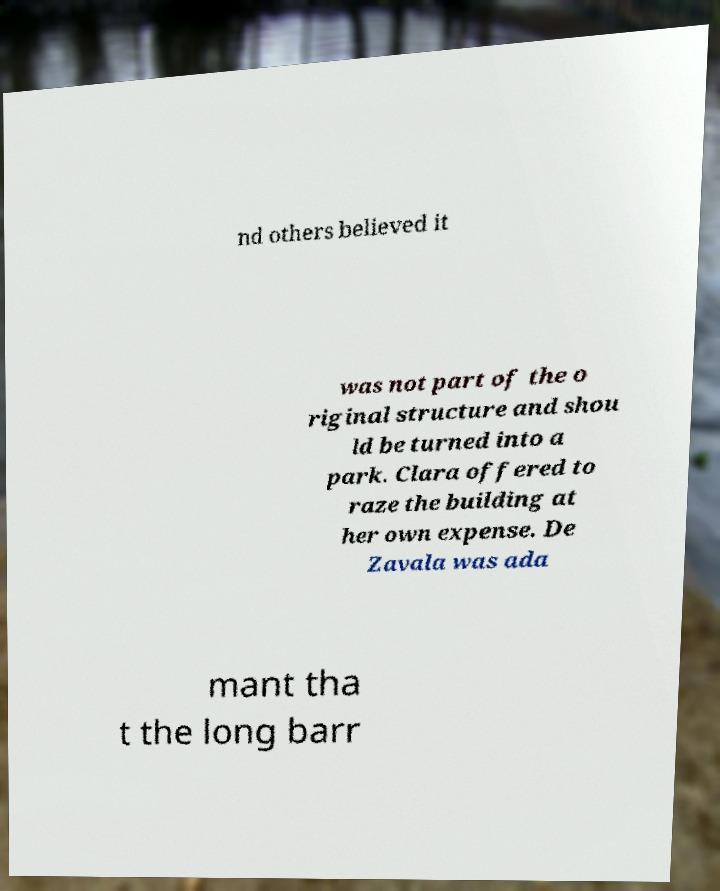Please identify and transcribe the text found in this image. nd others believed it was not part of the o riginal structure and shou ld be turned into a park. Clara offered to raze the building at her own expense. De Zavala was ada mant tha t the long barr 